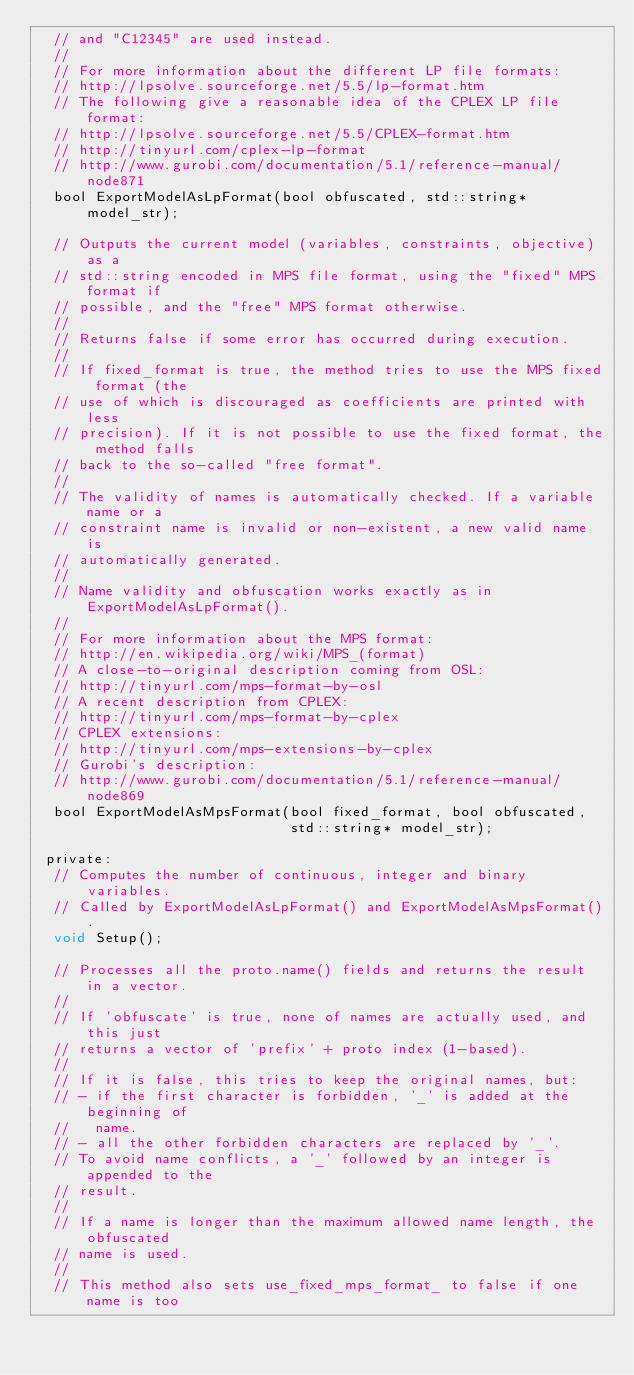Convert code to text. <code><loc_0><loc_0><loc_500><loc_500><_C_>  // and "C12345" are used instead.
  //
  // For more information about the different LP file formats:
  // http://lpsolve.sourceforge.net/5.5/lp-format.htm
  // The following give a reasonable idea of the CPLEX LP file format:
  // http://lpsolve.sourceforge.net/5.5/CPLEX-format.htm
  // http://tinyurl.com/cplex-lp-format
  // http://www.gurobi.com/documentation/5.1/reference-manual/node871
  bool ExportModelAsLpFormat(bool obfuscated, std::string* model_str);

  // Outputs the current model (variables, constraints, objective) as a
  // std::string encoded in MPS file format, using the "fixed" MPS format if
  // possible, and the "free" MPS format otherwise.
  //
  // Returns false if some error has occurred during execution.
  //
  // If fixed_format is true, the method tries to use the MPS fixed format (the
  // use of which is discouraged as coefficients are printed with less
  // precision). If it is not possible to use the fixed format, the method falls
  // back to the so-called "free format".
  //
  // The validity of names is automatically checked. If a variable name or a
  // constraint name is invalid or non-existent, a new valid name is
  // automatically generated.
  //
  // Name validity and obfuscation works exactly as in ExportModelAsLpFormat().
  //
  // For more information about the MPS format:
  // http://en.wikipedia.org/wiki/MPS_(format)
  // A close-to-original description coming from OSL:
  // http://tinyurl.com/mps-format-by-osl
  // A recent description from CPLEX:
  // http://tinyurl.com/mps-format-by-cplex
  // CPLEX extensions:
  // http://tinyurl.com/mps-extensions-by-cplex
  // Gurobi's description:
  // http://www.gurobi.com/documentation/5.1/reference-manual/node869
  bool ExportModelAsMpsFormat(bool fixed_format, bool obfuscated,
                              std::string* model_str);

 private:
  // Computes the number of continuous, integer and binary variables.
  // Called by ExportModelAsLpFormat() and ExportModelAsMpsFormat().
  void Setup();

  // Processes all the proto.name() fields and returns the result in a vector.
  //
  // If 'obfuscate' is true, none of names are actually used, and this just
  // returns a vector of 'prefix' + proto index (1-based).
  //
  // If it is false, this tries to keep the original names, but:
  // - if the first character is forbidden, '_' is added at the beginning of
  //   name.
  // - all the other forbidden characters are replaced by '_'.
  // To avoid name conflicts, a '_' followed by an integer is appended to the
  // result.
  //
  // If a name is longer than the maximum allowed name length, the obfuscated
  // name is used.
  //
  // This method also sets use_fixed_mps_format_ to false if one name is too</code> 